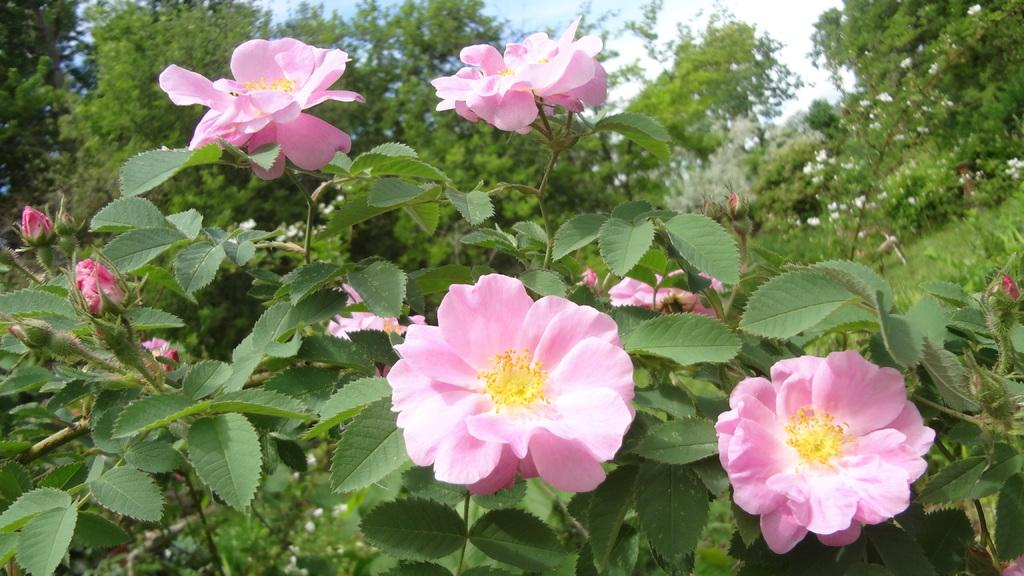What is the main focus of the image? The main focus of the image is flowers and buds in the center. What other elements can be seen in the image? There are leaves, a sky, trees, and more flowers visible in the image. Can you describe the background of the image? The background of the image includes a sky, trees, and flowers. What type of engine can be seen powering the flowers in the image? There is no engine present in the image; it features flowers and buds in the center. How many friends are visible in the image? There are no friends visible in the image; it features flowers, leaves, and a sky in the background. 